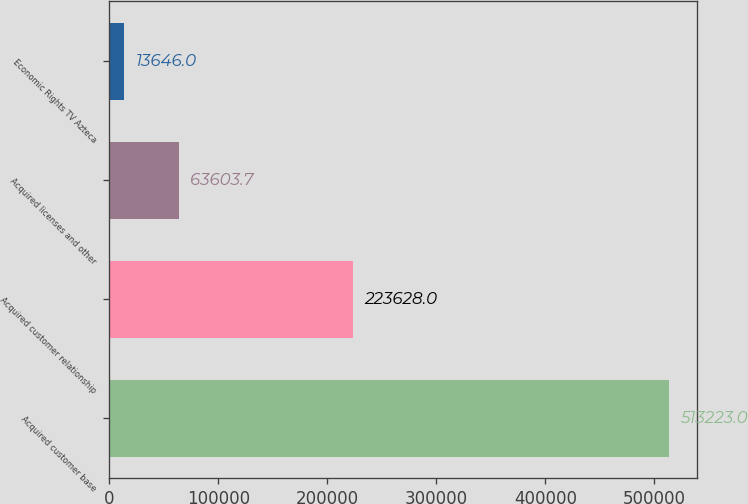<chart> <loc_0><loc_0><loc_500><loc_500><bar_chart><fcel>Acquired customer base<fcel>Acquired customer relationship<fcel>Acquired licenses and other<fcel>Economic Rights TV Azteca<nl><fcel>513223<fcel>223628<fcel>63603.7<fcel>13646<nl></chart> 